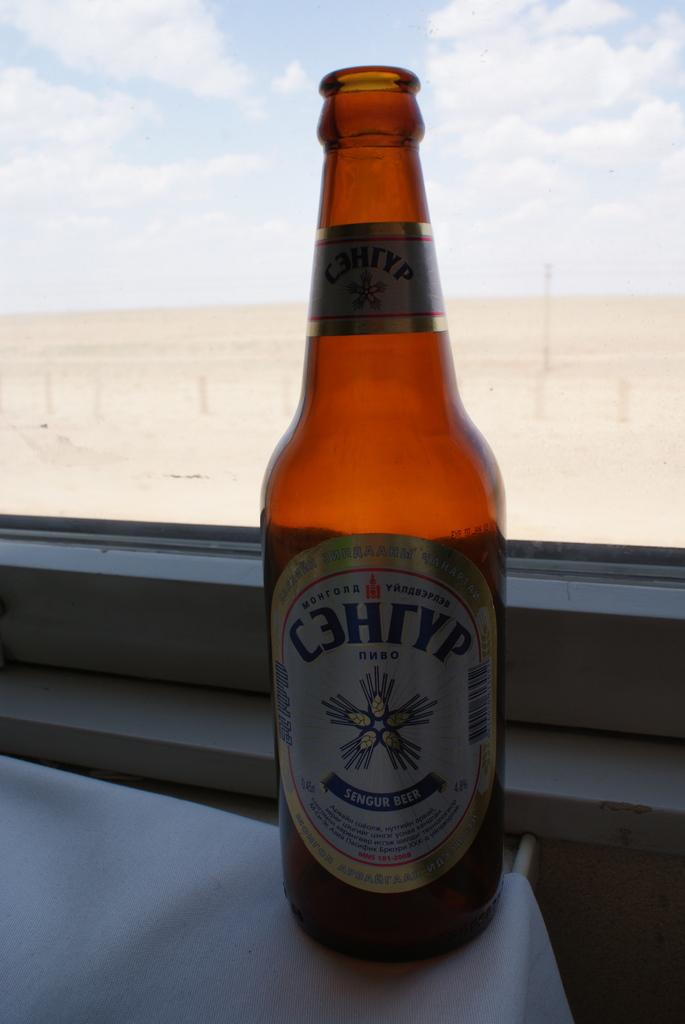<image>
Describe the image concisely. A foreign language bottle of beer with English that says SENGUR BEER. 